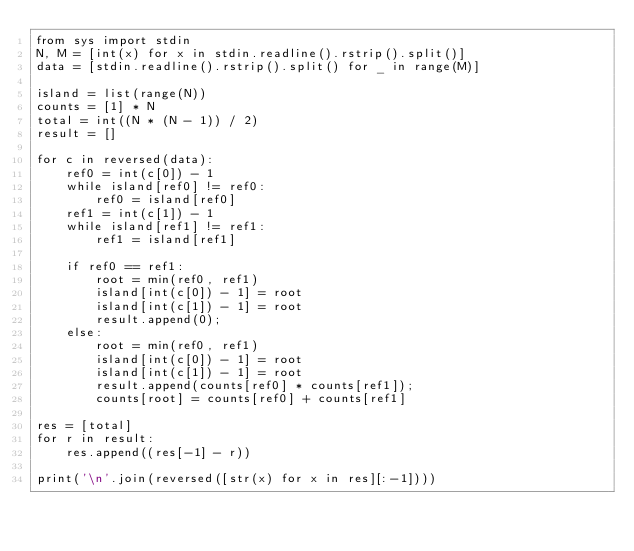<code> <loc_0><loc_0><loc_500><loc_500><_Python_>from sys import stdin
N, M = [int(x) for x in stdin.readline().rstrip().split()]
data = [stdin.readline().rstrip().split() for _ in range(M)]

island = list(range(N))
counts = [1] * N
total = int((N * (N - 1)) / 2)
result = []

for c in reversed(data):
    ref0 = int(c[0]) - 1
    while island[ref0] != ref0:
        ref0 = island[ref0]
    ref1 = int(c[1]) - 1
    while island[ref1] != ref1:
        ref1 = island[ref1]

    if ref0 == ref1:
        root = min(ref0, ref1)
        island[int(c[0]) - 1] = root
        island[int(c[1]) - 1] = root
        result.append(0);
    else:
        root = min(ref0, ref1)
        island[int(c[0]) - 1] = root
        island[int(c[1]) - 1] = root
        result.append(counts[ref0] * counts[ref1]);
        counts[root] = counts[ref0] + counts[ref1]

res = [total]
for r in result:
    res.append((res[-1] - r))

print('\n'.join(reversed([str(x) for x in res][:-1])))
</code> 